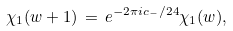<formula> <loc_0><loc_0><loc_500><loc_500>\chi _ { 1 } ( w + 1 ) \, = \, e ^ { - 2 \pi i c _ { - } / 2 4 } \chi _ { 1 } ( w ) ,</formula> 